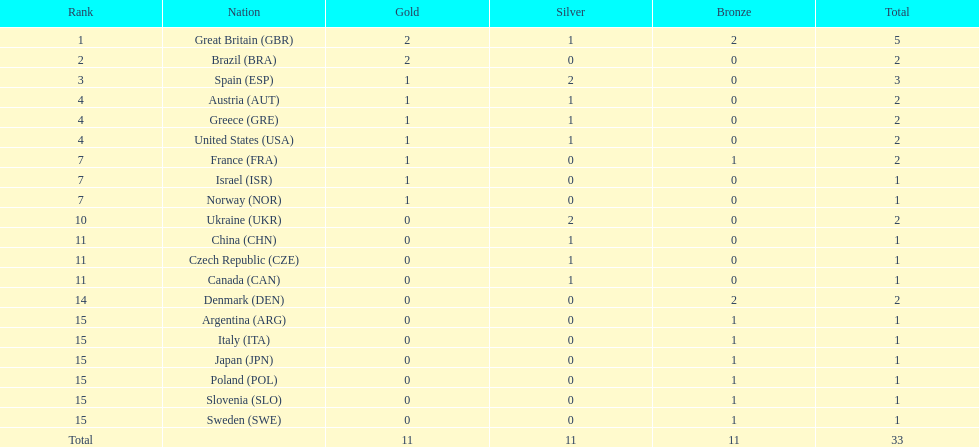Which nation was the only one to receive 3 medals? Spain (ESP). 